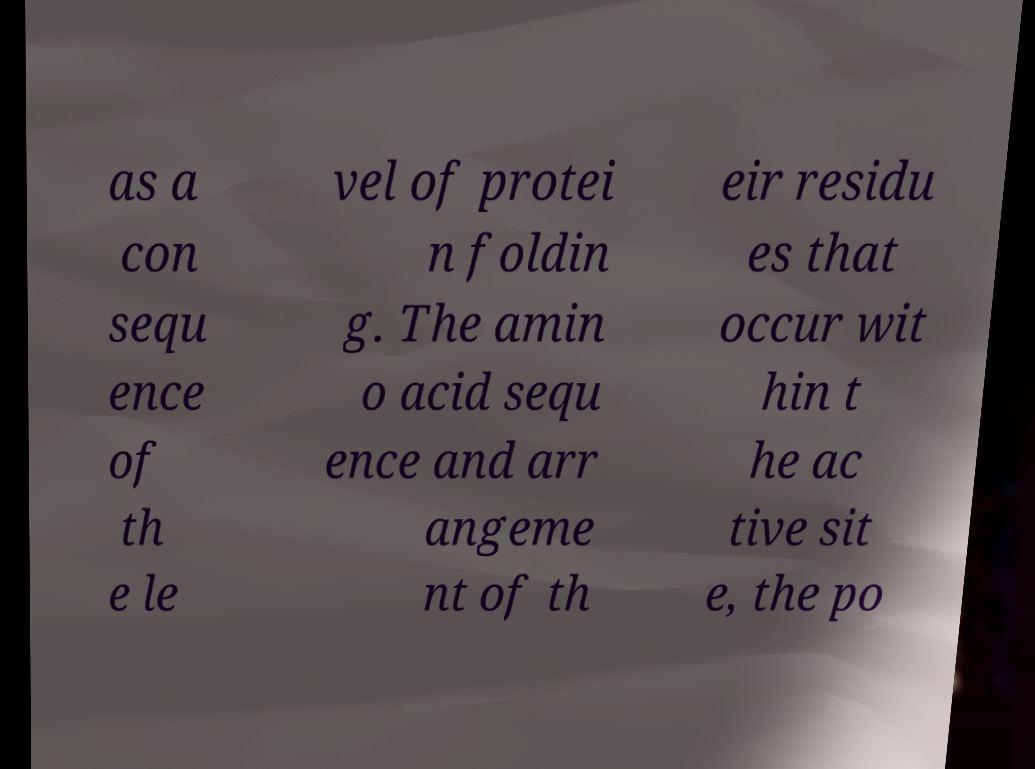I need the written content from this picture converted into text. Can you do that? as a con sequ ence of th e le vel of protei n foldin g. The amin o acid sequ ence and arr angeme nt of th eir residu es that occur wit hin t he ac tive sit e, the po 